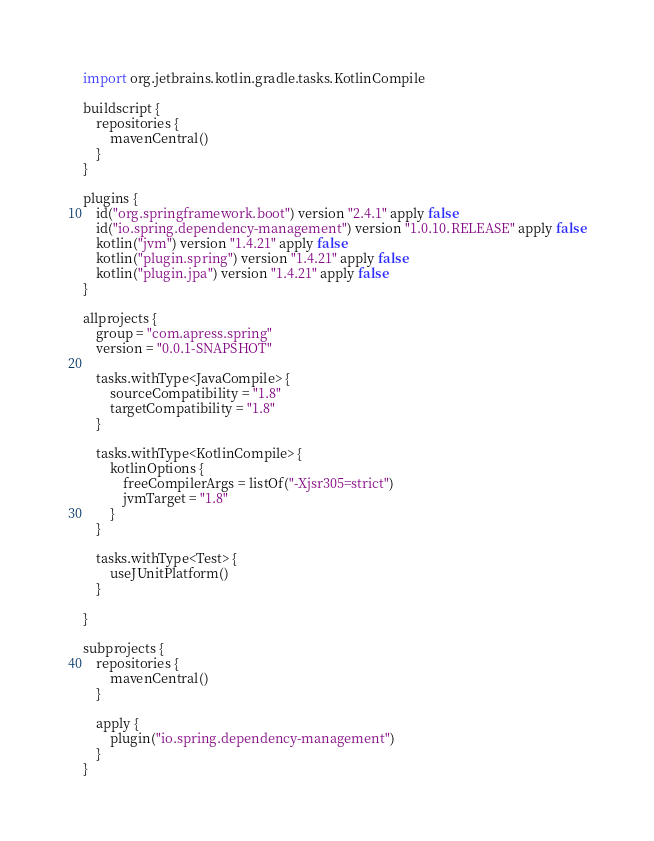Convert code to text. <code><loc_0><loc_0><loc_500><loc_500><_Kotlin_>import org.jetbrains.kotlin.gradle.tasks.KotlinCompile

buildscript {
    repositories {
        mavenCentral()
    }
}

plugins {
    id("org.springframework.boot") version "2.4.1" apply false
    id("io.spring.dependency-management") version "1.0.10.RELEASE" apply false
    kotlin("jvm") version "1.4.21" apply false
    kotlin("plugin.spring") version "1.4.21" apply false
    kotlin("plugin.jpa") version "1.4.21" apply false
}

allprojects {
    group = "com.apress.spring"
    version = "0.0.1-SNAPSHOT"

    tasks.withType<JavaCompile> {
        sourceCompatibility = "1.8"
        targetCompatibility = "1.8"
    }

    tasks.withType<KotlinCompile> {
        kotlinOptions {
            freeCompilerArgs = listOf("-Xjsr305=strict")
            jvmTarget = "1.8"
        }
    }

    tasks.withType<Test> {
        useJUnitPlatform()
    }

}

subprojects {
    repositories {
        mavenCentral()
    }

    apply {
        plugin("io.spring.dependency-management")
    }
}
</code> 